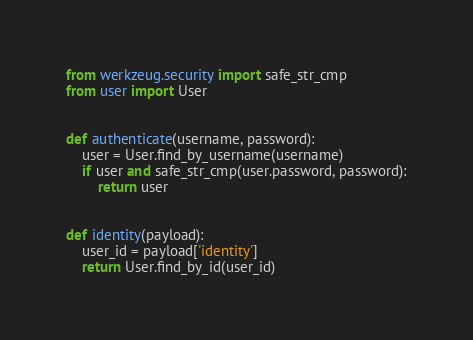<code> <loc_0><loc_0><loc_500><loc_500><_Python_>from werkzeug.security import safe_str_cmp
from user import User


def authenticate(username, password):
    user = User.find_by_username(username)
    if user and safe_str_cmp(user.password, password):
        return user


def identity(payload):
    user_id = payload['identity']
    return User.find_by_id(user_id)

</code> 